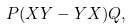<formula> <loc_0><loc_0><loc_500><loc_500>P ( X Y - Y X ) Q ,</formula> 